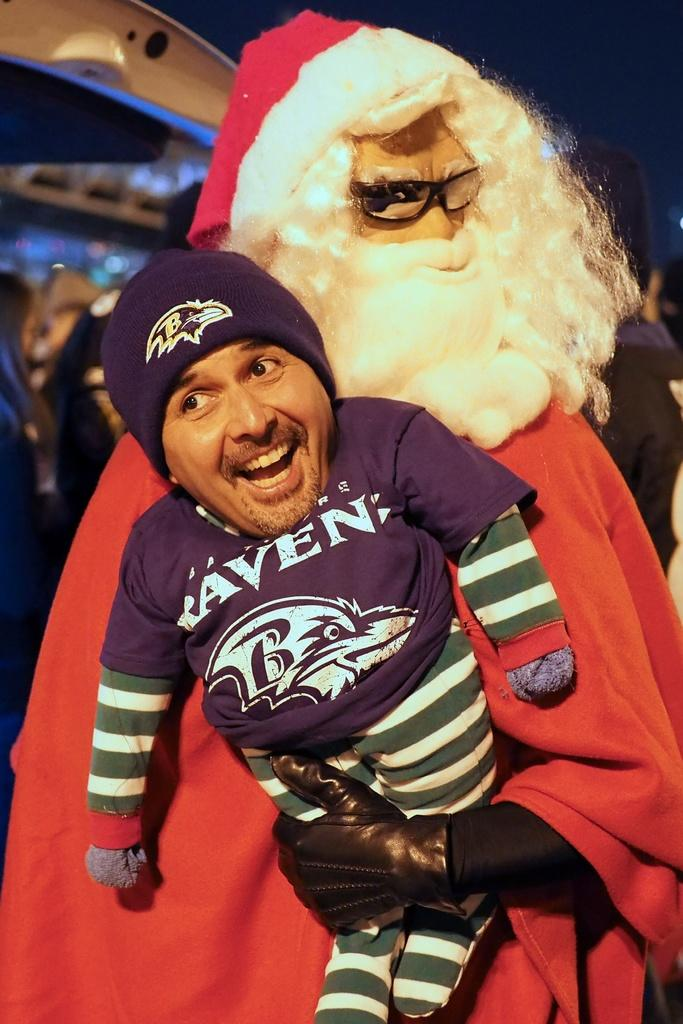What is the person in the image wearing? The person in the image is wearing a Santa costume. What is the person holding in their hands? The person is holding a toy in their hands. Can you describe the toy's appearance? The toy's face is covered with a man's smiley face. Is there a quilt visible in the image? No, there is no quilt present in the image. Does the existence of the toy in the image prove the existence of Santa Claus? The presence of the toy in the image does not prove the existence of Santa Claus, as it is a person dressed in a Santa costume holding the toy. 